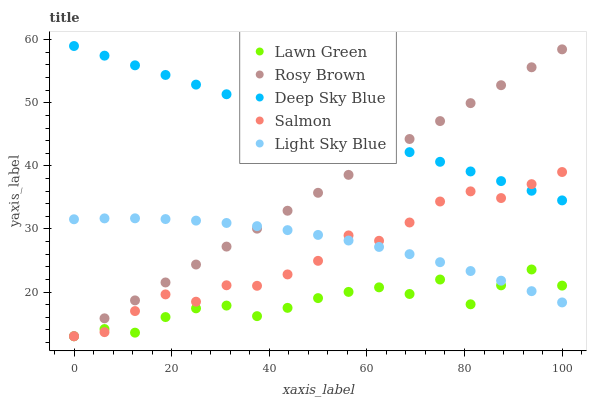Does Lawn Green have the minimum area under the curve?
Answer yes or no. Yes. Does Deep Sky Blue have the maximum area under the curve?
Answer yes or no. Yes. Does Rosy Brown have the minimum area under the curve?
Answer yes or no. No. Does Rosy Brown have the maximum area under the curve?
Answer yes or no. No. Is Deep Sky Blue the smoothest?
Answer yes or no. Yes. Is Lawn Green the roughest?
Answer yes or no. Yes. Is Rosy Brown the smoothest?
Answer yes or no. No. Is Rosy Brown the roughest?
Answer yes or no. No. Does Lawn Green have the lowest value?
Answer yes or no. Yes. Does Deep Sky Blue have the lowest value?
Answer yes or no. No. Does Deep Sky Blue have the highest value?
Answer yes or no. Yes. Does Rosy Brown have the highest value?
Answer yes or no. No. Is Lawn Green less than Deep Sky Blue?
Answer yes or no. Yes. Is Deep Sky Blue greater than Light Sky Blue?
Answer yes or no. Yes. Does Light Sky Blue intersect Rosy Brown?
Answer yes or no. Yes. Is Light Sky Blue less than Rosy Brown?
Answer yes or no. No. Is Light Sky Blue greater than Rosy Brown?
Answer yes or no. No. Does Lawn Green intersect Deep Sky Blue?
Answer yes or no. No. 